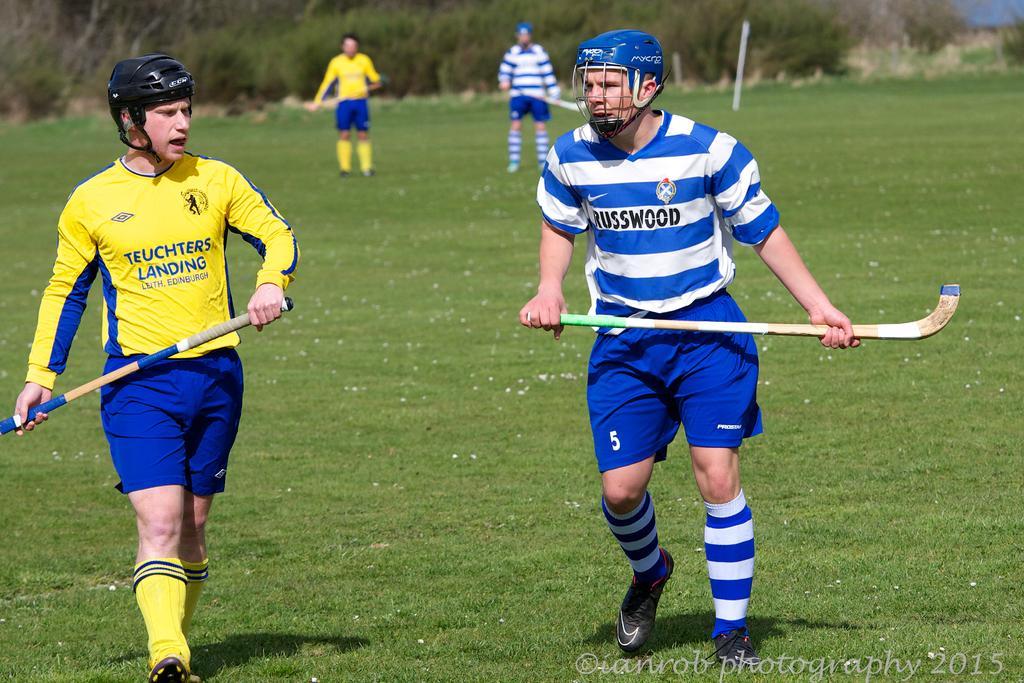Can you describe this image briefly? In this image we can see two persons, hockey stick and other objects. In the background of the image there are persons, grass, the sky and other objects. At the bottom of the image there is the grass. On the image there is a watermark. 